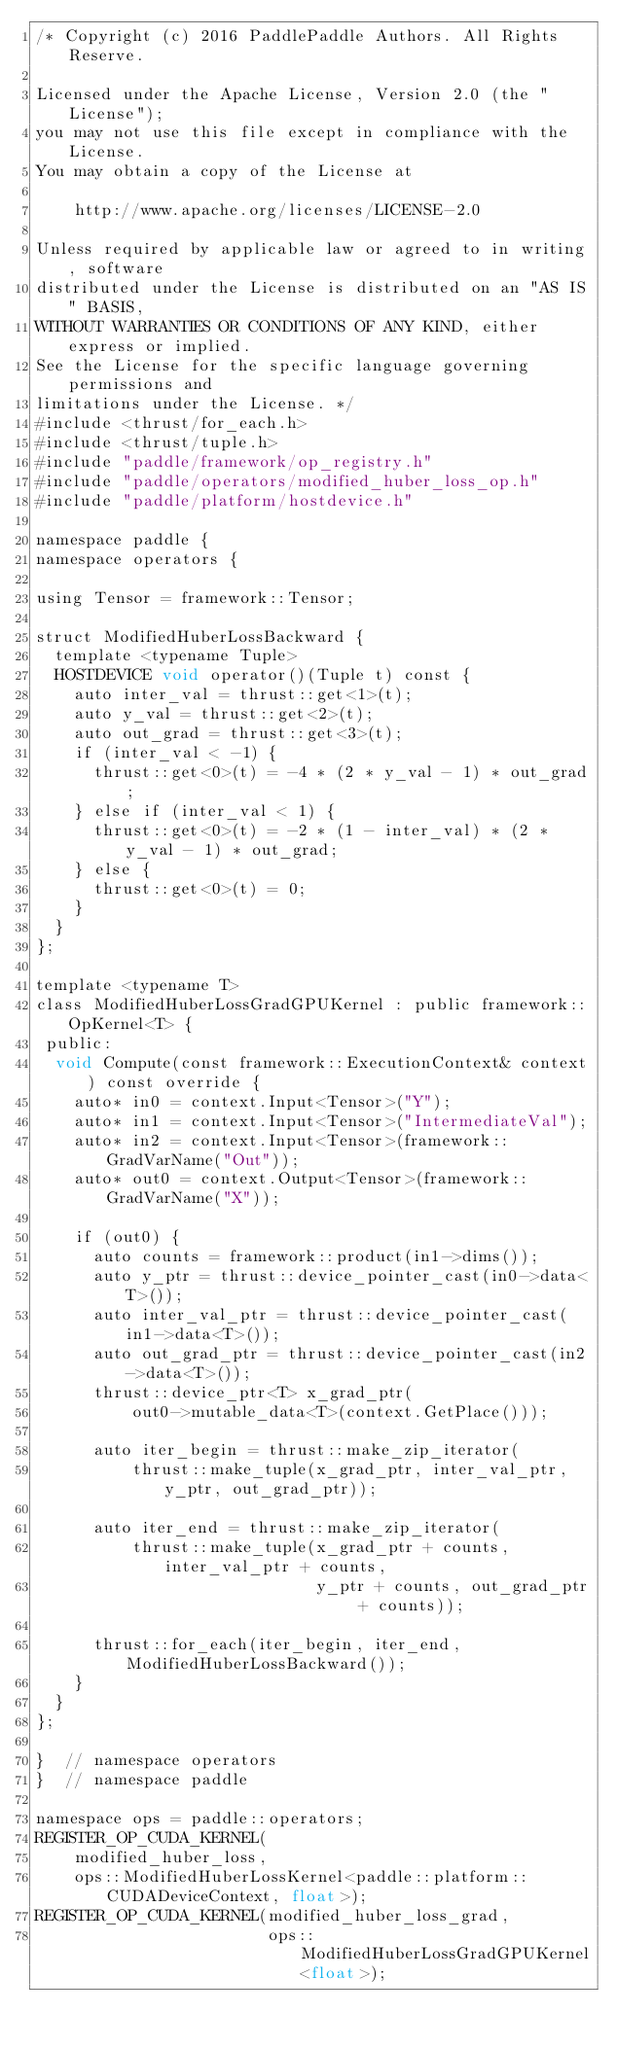Convert code to text. <code><loc_0><loc_0><loc_500><loc_500><_Cuda_>/* Copyright (c) 2016 PaddlePaddle Authors. All Rights Reserve.

Licensed under the Apache License, Version 2.0 (the "License");
you may not use this file except in compliance with the License.
You may obtain a copy of the License at

    http://www.apache.org/licenses/LICENSE-2.0

Unless required by applicable law or agreed to in writing, software
distributed under the License is distributed on an "AS IS" BASIS,
WITHOUT WARRANTIES OR CONDITIONS OF ANY KIND, either express or implied.
See the License for the specific language governing permissions and
limitations under the License. */
#include <thrust/for_each.h>
#include <thrust/tuple.h>
#include "paddle/framework/op_registry.h"
#include "paddle/operators/modified_huber_loss_op.h"
#include "paddle/platform/hostdevice.h"

namespace paddle {
namespace operators {

using Tensor = framework::Tensor;

struct ModifiedHuberLossBackward {
  template <typename Tuple>
  HOSTDEVICE void operator()(Tuple t) const {
    auto inter_val = thrust::get<1>(t);
    auto y_val = thrust::get<2>(t);
    auto out_grad = thrust::get<3>(t);
    if (inter_val < -1) {
      thrust::get<0>(t) = -4 * (2 * y_val - 1) * out_grad;
    } else if (inter_val < 1) {
      thrust::get<0>(t) = -2 * (1 - inter_val) * (2 * y_val - 1) * out_grad;
    } else {
      thrust::get<0>(t) = 0;
    }
  }
};

template <typename T>
class ModifiedHuberLossGradGPUKernel : public framework::OpKernel<T> {
 public:
  void Compute(const framework::ExecutionContext& context) const override {
    auto* in0 = context.Input<Tensor>("Y");
    auto* in1 = context.Input<Tensor>("IntermediateVal");
    auto* in2 = context.Input<Tensor>(framework::GradVarName("Out"));
    auto* out0 = context.Output<Tensor>(framework::GradVarName("X"));

    if (out0) {
      auto counts = framework::product(in1->dims());
      auto y_ptr = thrust::device_pointer_cast(in0->data<T>());
      auto inter_val_ptr = thrust::device_pointer_cast(in1->data<T>());
      auto out_grad_ptr = thrust::device_pointer_cast(in2->data<T>());
      thrust::device_ptr<T> x_grad_ptr(
          out0->mutable_data<T>(context.GetPlace()));

      auto iter_begin = thrust::make_zip_iterator(
          thrust::make_tuple(x_grad_ptr, inter_val_ptr, y_ptr, out_grad_ptr));

      auto iter_end = thrust::make_zip_iterator(
          thrust::make_tuple(x_grad_ptr + counts, inter_val_ptr + counts,
                             y_ptr + counts, out_grad_ptr + counts));

      thrust::for_each(iter_begin, iter_end, ModifiedHuberLossBackward());
    }
  }
};

}  // namespace operators
}  // namespace paddle

namespace ops = paddle::operators;
REGISTER_OP_CUDA_KERNEL(
    modified_huber_loss,
    ops::ModifiedHuberLossKernel<paddle::platform::CUDADeviceContext, float>);
REGISTER_OP_CUDA_KERNEL(modified_huber_loss_grad,
                        ops::ModifiedHuberLossGradGPUKernel<float>);
</code> 